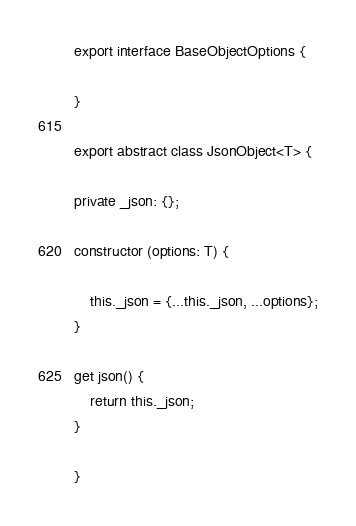<code> <loc_0><loc_0><loc_500><loc_500><_TypeScript_>

export interface BaseObjectOptions {

}

export abstract class JsonObject<T> {

private _json: {};

constructor (options: T) {

    this._json = {...this._json, ...options};
}

get json() {
    return this._json;
}

}
</code> 